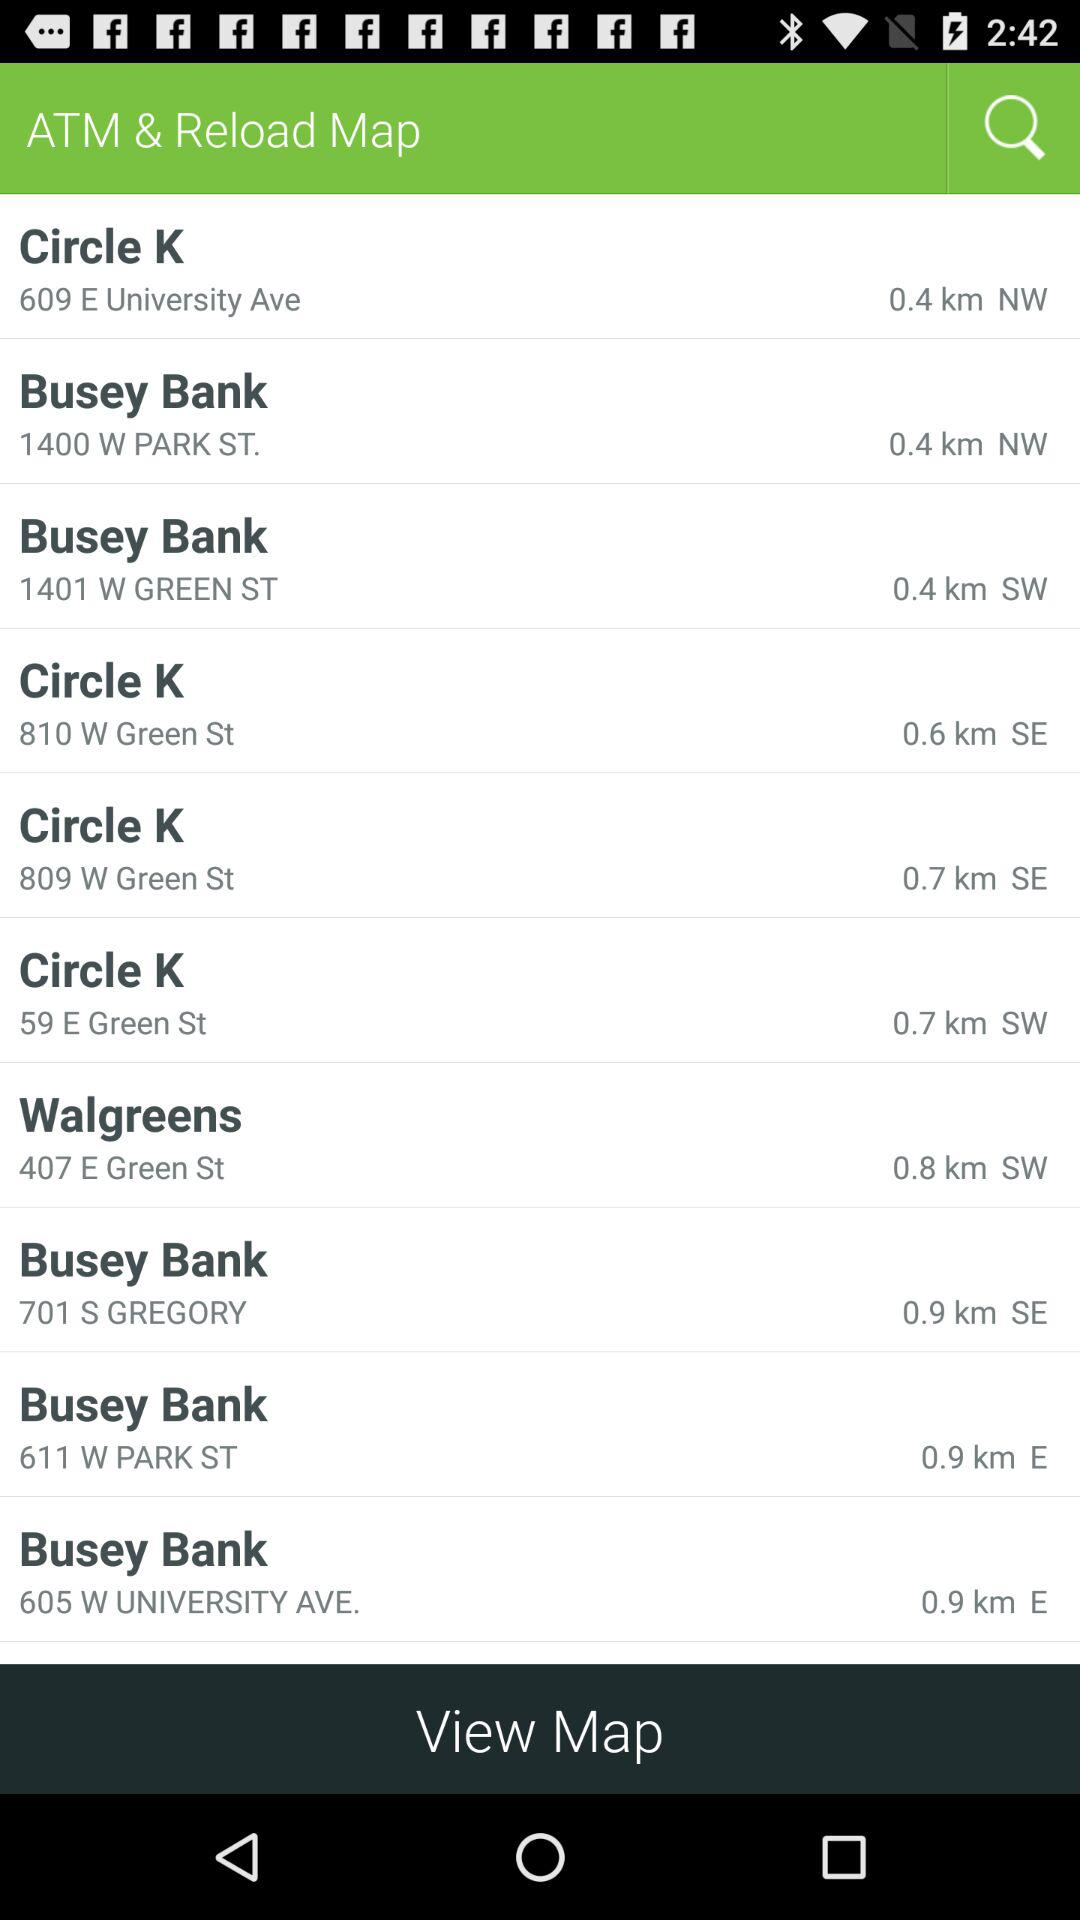What ATM is at 611 W. Park St.? The ATM is "Busey Bank". 